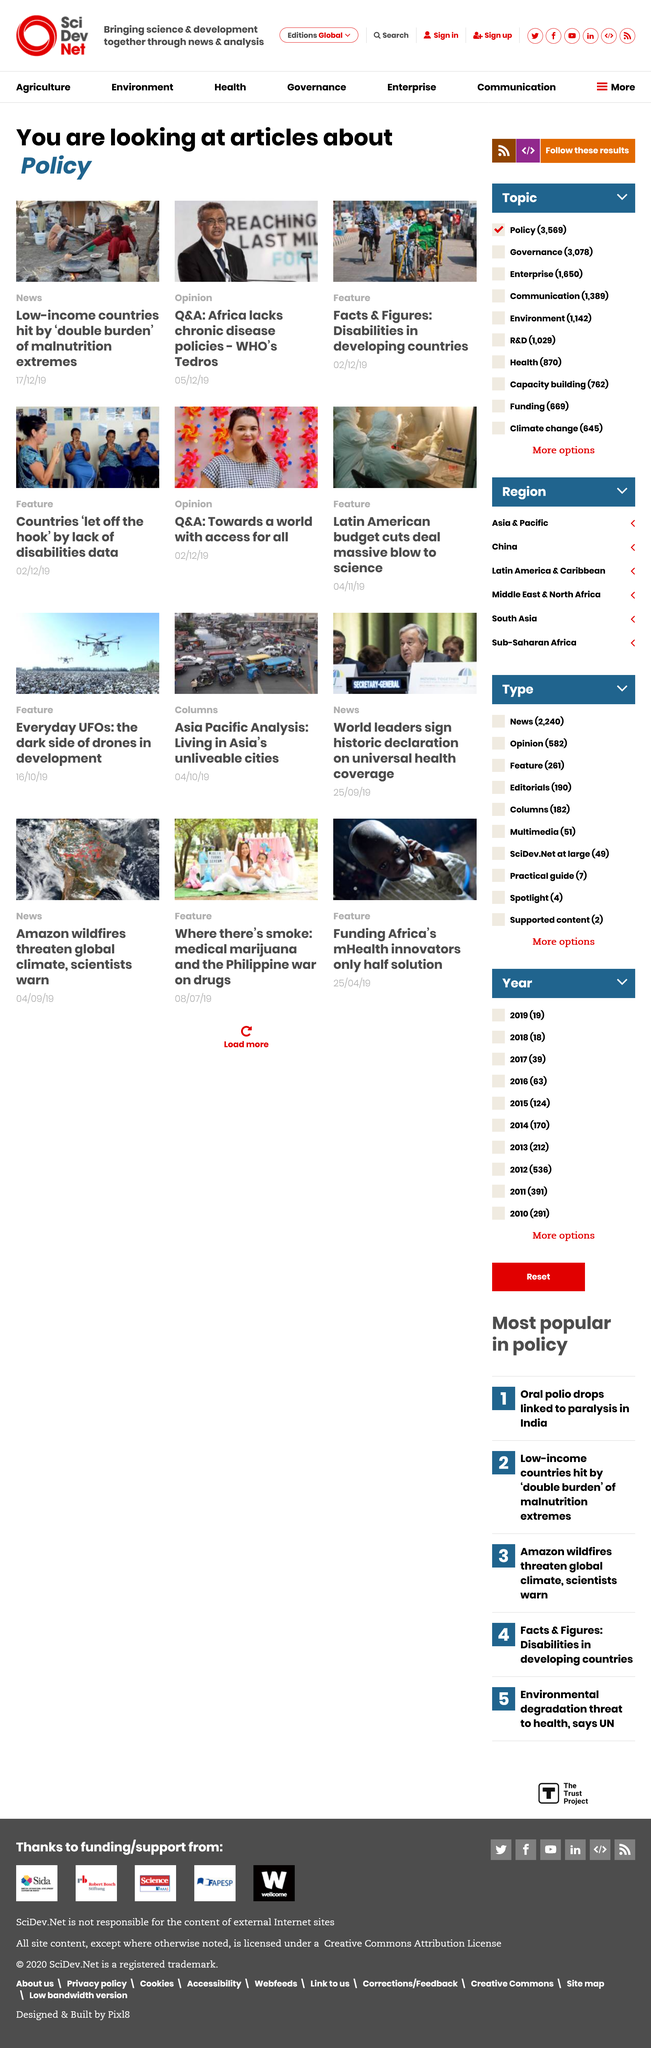Give some essential details in this illustration. The articles' topic is policy, and they are about it. The "double burden" of malnutrition, characterized by both under-nutrition and overweight and obesity, is prevalent in low-income countries. There are 3 additional articles on the page. 